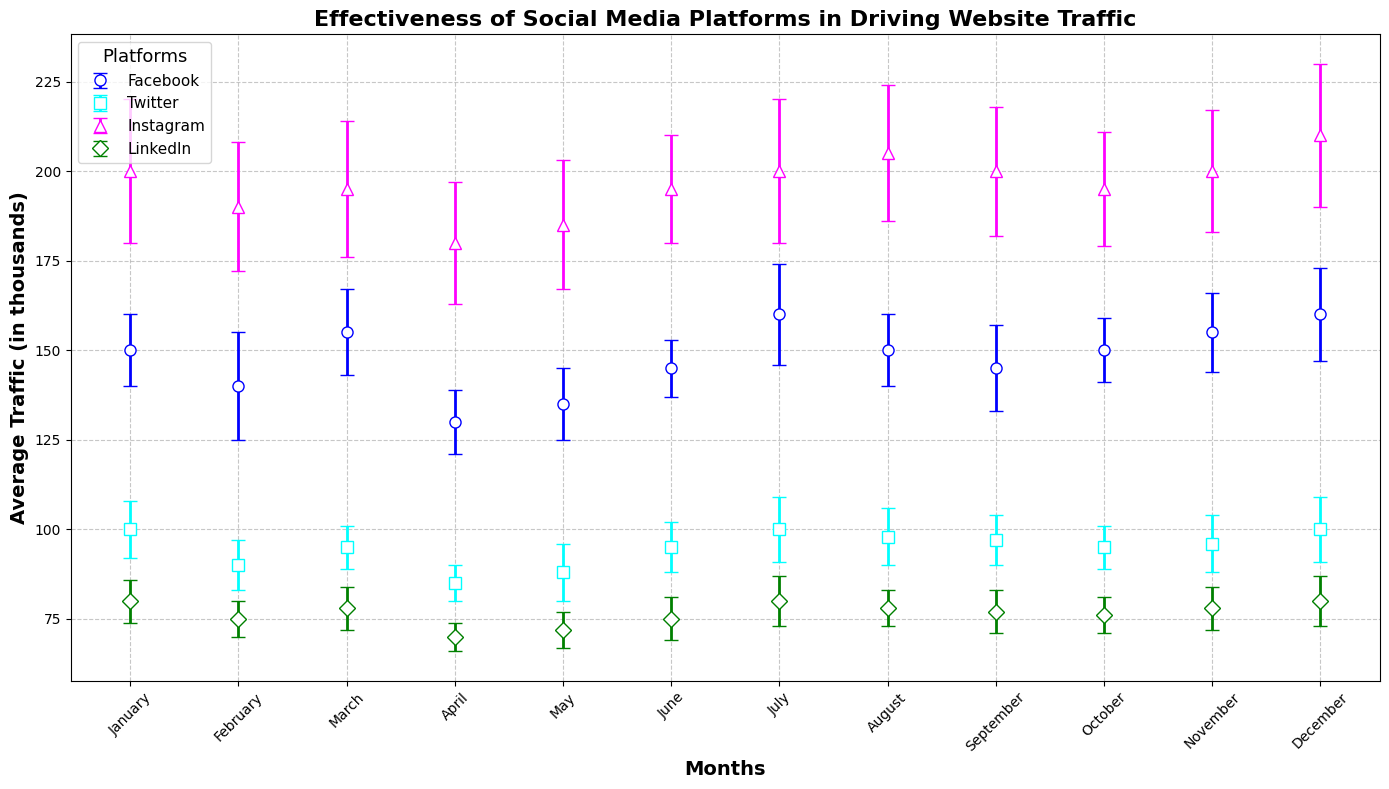How does the average traffic for Facebook in December compare to that for Instagram in December? Look at the points for Facebook and Instagram in December. Facebook has an average traffic of 160,000, while Instagram has an average traffic of 210,000. The average traffic for Instagram in December is higher.
Answer: Instagram's traffic is higher What's the total combined average traffic driven by Twitter and LinkedIn in January? Find the January values for Twitter and LinkedIn. Twitter's average traffic is 100,000 and LinkedIn's is 80,000. Adding these together, the total is 100,000 + 80,000 = 180,000.
Answer: 180,000 Which platform had the highest average traffic in any given month, and what was that traffic? Examine all the peaks in the figure. Instagram in December had the highest average traffic of 210,000.
Answer: Instagram, 210,000 What is the difference in average traffic between the highest and lowest months for Facebook? Identify Facebook's highest and lowest months. The highest month is July and December with 160,000. The lowest month is April with 130,000. The difference is 160,000 - 130,000 = 30,000.
Answer: 30,000 Which platform shows the most variance in traffic? Compare the error bars (indicating standard deviation) for all platforms. Instagram consistently has larger error bars, implying greater variance in traffic.
Answer: Instagram Across all months, which platform shows the least variation in traffic? Look at the error bars throughout the months for each platform. Facebook and LinkedIn have relatively smaller error bars, but LinkedIn has more uniform error bars.
Answer: LinkedIn Considering the month of June, how much more traffic does Instagram drive compared to Twitter? Look at the June values for both Instagram and Twitter. Instagram's average traffic is 195,000 and Twitter's is 95,000. The difference is 195,000 - 95,000 = 100,000.
Answer: 100,000 What is the average monthly traffic driven by LinkedIn from January to December? Add up the monthly traffic values for LinkedIn (80+75+78+70+72+75+80+78+77+76+78+80 = 919,000) and divide by 12. The average is 919,000 / 12 = 76,583.33.
Answer: 76,583.33 